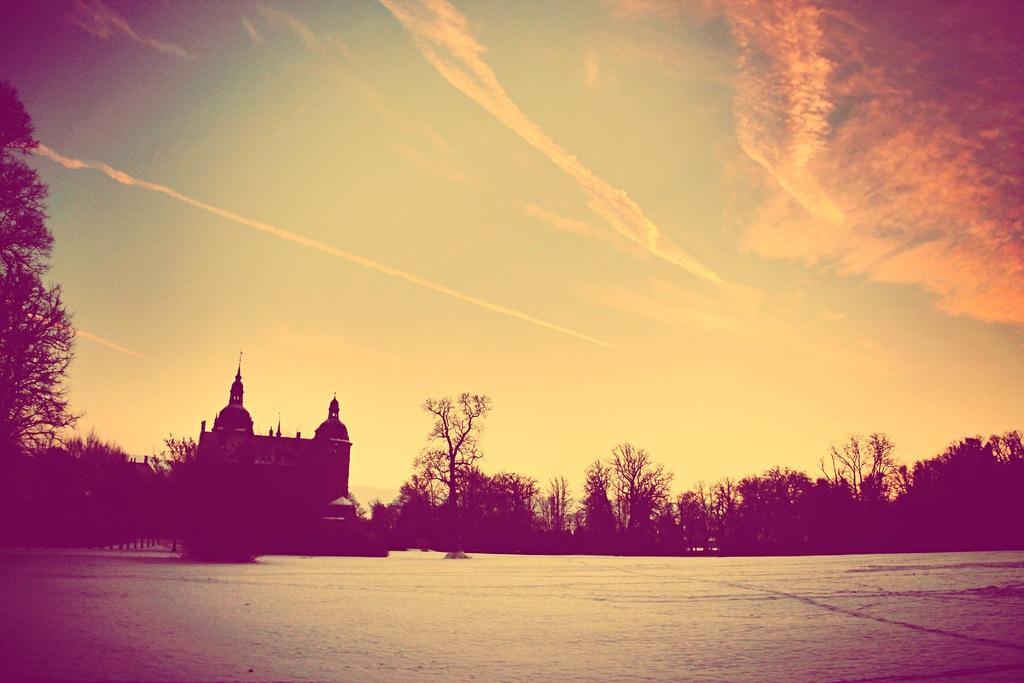Could you give a brief overview of what you see in this image? In this picture I can see the water at the bottom, in the background there is a building and there are trees. At the top there is the sky, it is an edited image. 